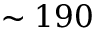<formula> <loc_0><loc_0><loc_500><loc_500>\sim 1 9 0</formula> 